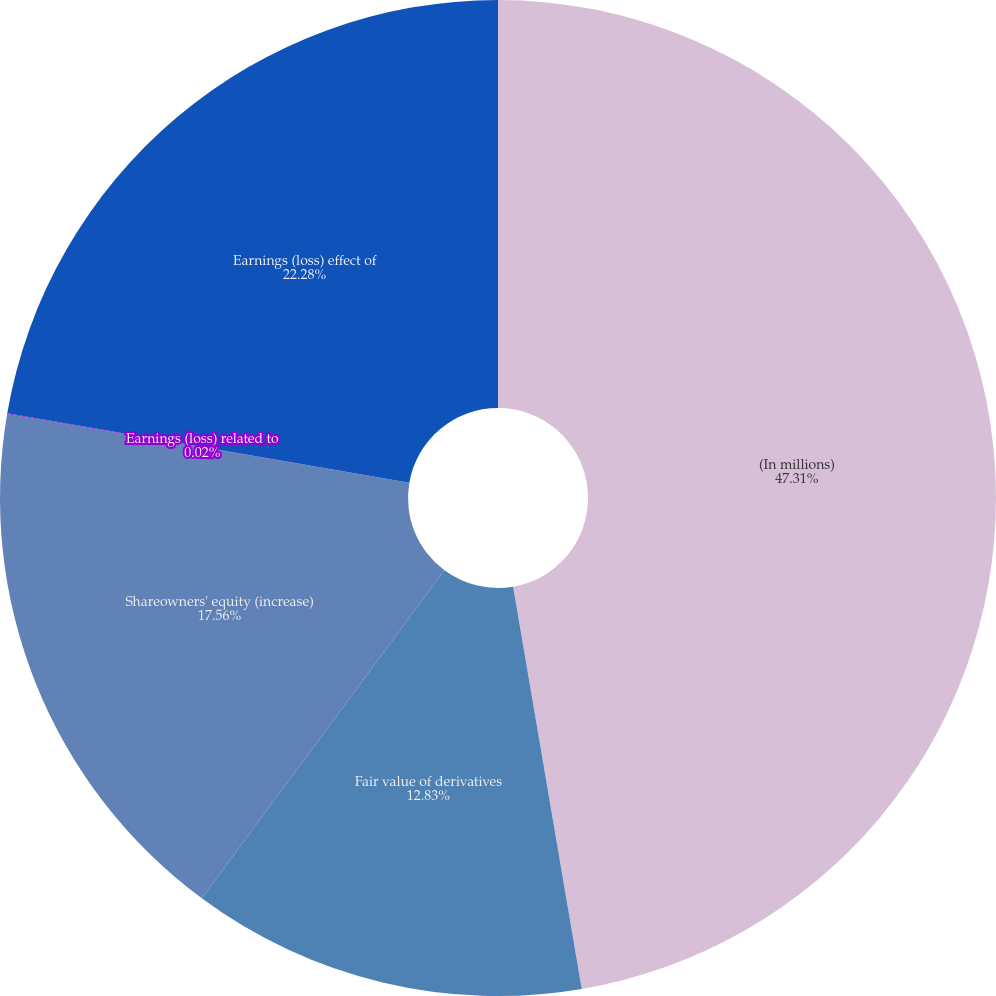Convert chart to OTSL. <chart><loc_0><loc_0><loc_500><loc_500><pie_chart><fcel>(In millions)<fcel>Fair value of derivatives<fcel>Shareowners' equity (increase)<fcel>Earnings (loss) related to<fcel>Earnings (loss) effect of<nl><fcel>47.31%<fcel>12.83%<fcel>17.56%<fcel>0.02%<fcel>22.28%<nl></chart> 